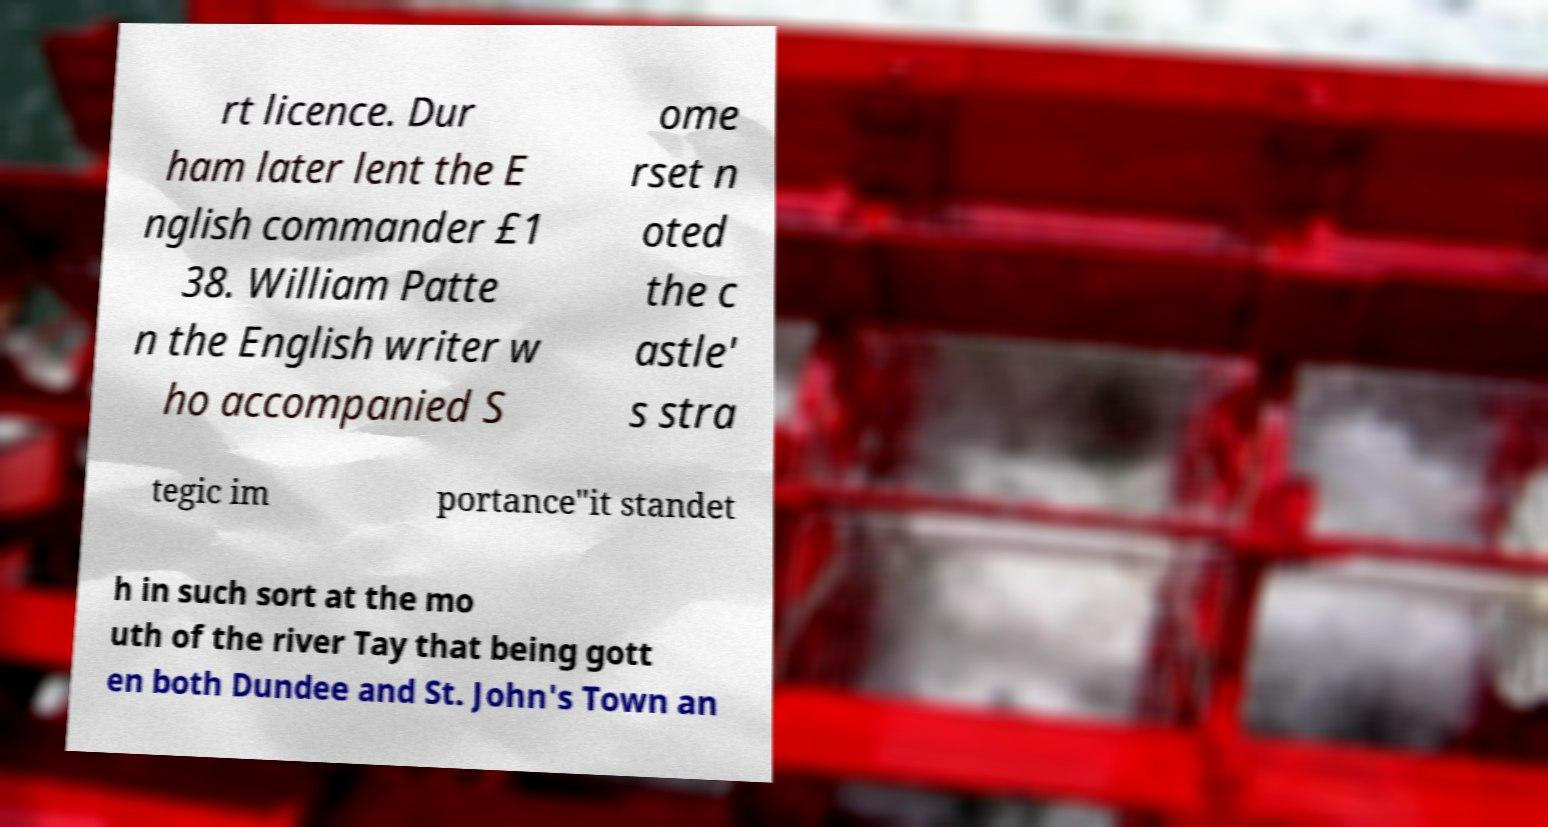There's text embedded in this image that I need extracted. Can you transcribe it verbatim? rt licence. Dur ham later lent the E nglish commander £1 38. William Patte n the English writer w ho accompanied S ome rset n oted the c astle' s stra tegic im portance"it standet h in such sort at the mo uth of the river Tay that being gott en both Dundee and St. John's Town an 